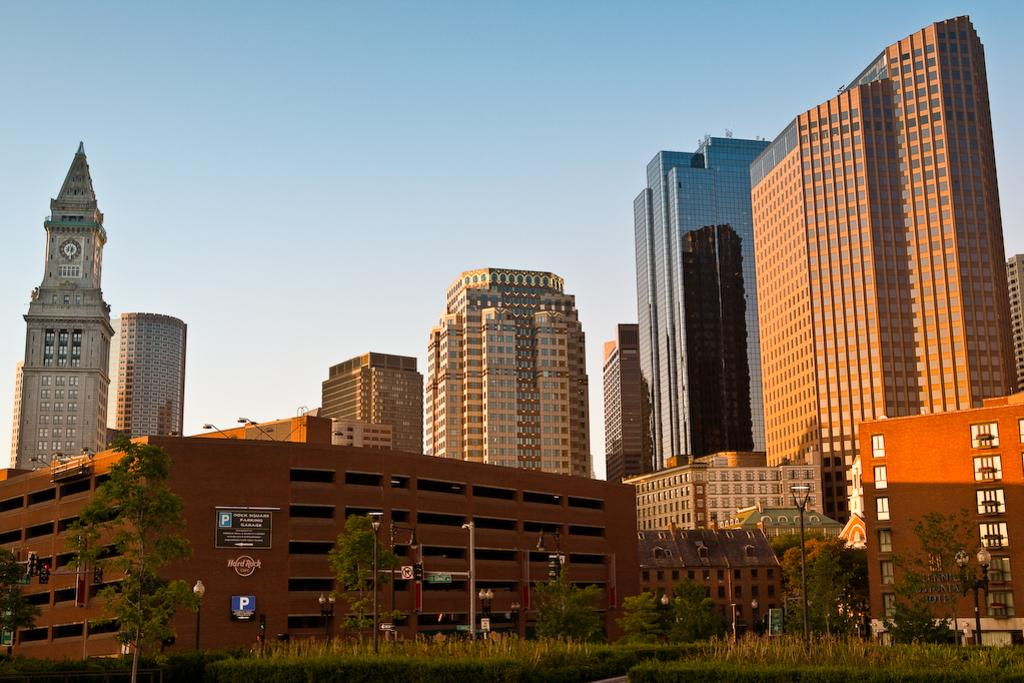What can be seen in the foreground of the picture? In the foreground of the picture, there are trees, street lights, plants, and a path. What type of structures are visible in the picture? Buildings can be seen in the foreground and middle of the picture. What is visible at the top of the picture? The sky is visible at the top of the picture. What type of paper is being used to turn the afterthought into a reality in the image? There is no paper or afterthought present in the image; it features trees, street lights, plants, a path, buildings, and the sky. 